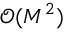<formula> <loc_0><loc_0><loc_500><loc_500>\mathcal { O } ( M ^ { 2 } )</formula> 